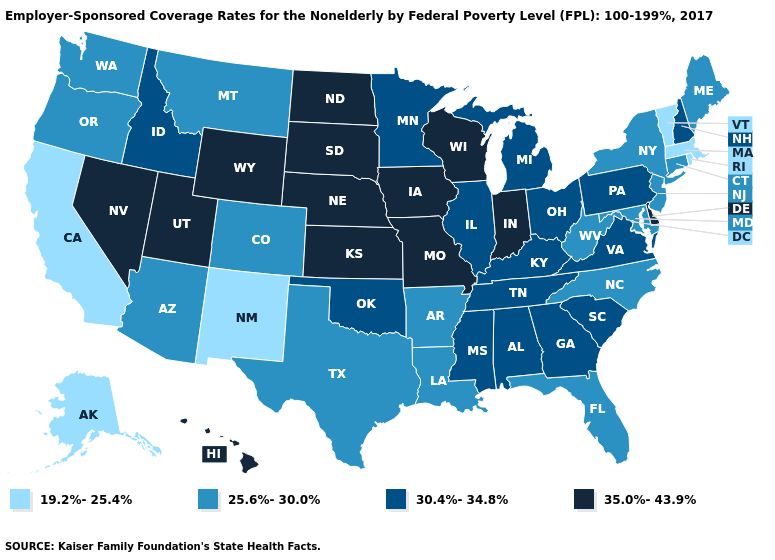What is the highest value in the USA?
Be succinct. 35.0%-43.9%. What is the highest value in the West ?
Keep it brief. 35.0%-43.9%. Among the states that border Oregon , does Washington have the highest value?
Give a very brief answer. No. Is the legend a continuous bar?
Give a very brief answer. No. Does New Jersey have a higher value than Hawaii?
Answer briefly. No. Does Oregon have the lowest value in the USA?
Write a very short answer. No. Does Idaho have the lowest value in the West?
Short answer required. No. Does Minnesota have the highest value in the MidWest?
Quick response, please. No. Name the states that have a value in the range 30.4%-34.8%?
Write a very short answer. Alabama, Georgia, Idaho, Illinois, Kentucky, Michigan, Minnesota, Mississippi, New Hampshire, Ohio, Oklahoma, Pennsylvania, South Carolina, Tennessee, Virginia. Which states have the lowest value in the USA?
Write a very short answer. Alaska, California, Massachusetts, New Mexico, Rhode Island, Vermont. Does the first symbol in the legend represent the smallest category?
Give a very brief answer. Yes. Among the states that border Alabama , which have the lowest value?
Short answer required. Florida. What is the lowest value in the USA?
Keep it brief. 19.2%-25.4%. What is the highest value in the USA?
Write a very short answer. 35.0%-43.9%. Among the states that border Maine , which have the highest value?
Give a very brief answer. New Hampshire. 